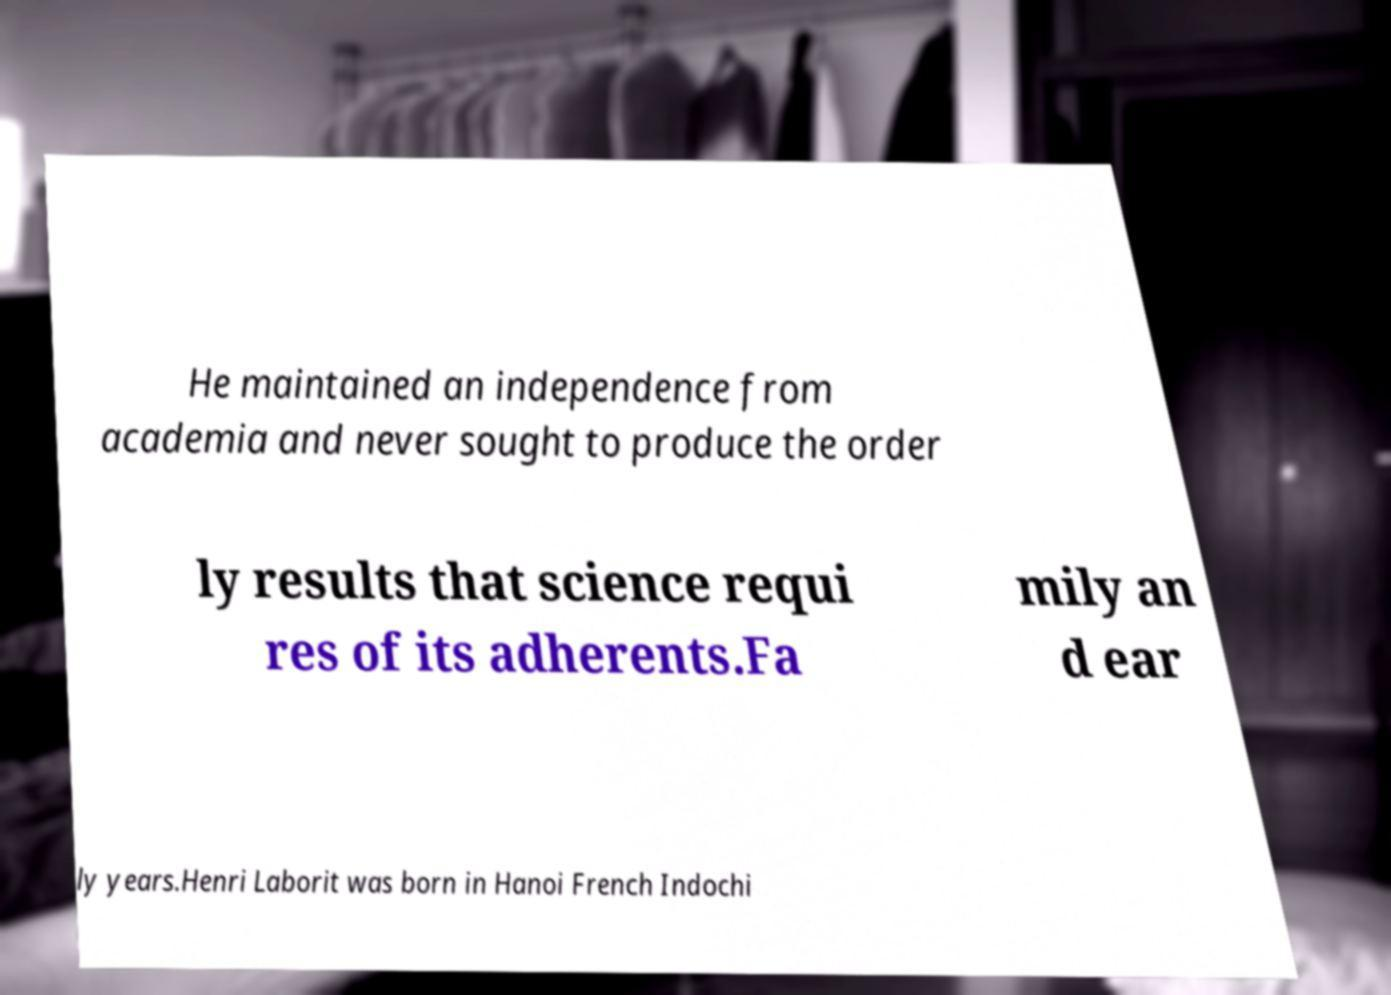Can you accurately transcribe the text from the provided image for me? He maintained an independence from academia and never sought to produce the order ly results that science requi res of its adherents.Fa mily an d ear ly years.Henri Laborit was born in Hanoi French Indochi 